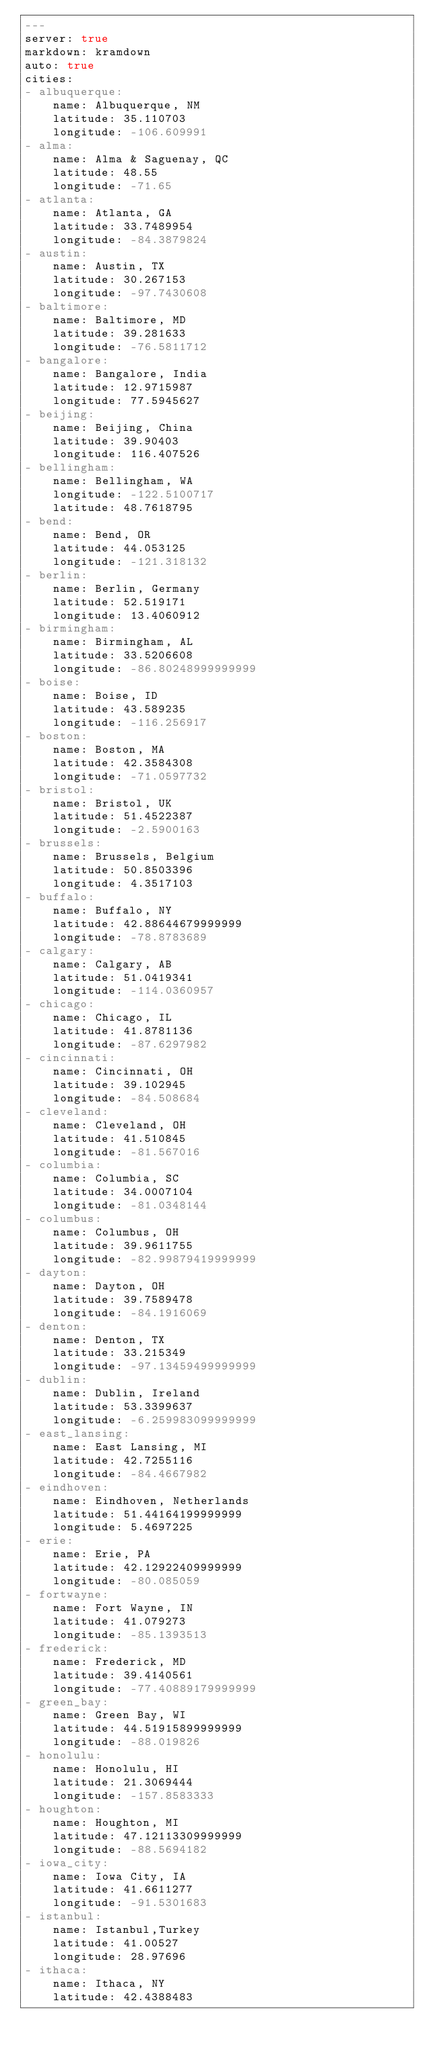Convert code to text. <code><loc_0><loc_0><loc_500><loc_500><_YAML_>---
server: true
markdown: kramdown
auto: true
cities:
- albuquerque:
    name: Albuquerque, NM
    latitude: 35.110703
    longitude: -106.609991
- alma:
    name: Alma & Saguenay, QC
    latitude: 48.55
    longitude: -71.65
- atlanta:
    name: Atlanta, GA
    latitude: 33.7489954
    longitude: -84.3879824
- austin:
    name: Austin, TX
    latitude: 30.267153
    longitude: -97.7430608
- baltimore:
    name: Baltimore, MD
    latitude: 39.281633
    longitude: -76.5811712
- bangalore:
    name: Bangalore, India
    latitude: 12.9715987
    longitude: 77.5945627
- beijing:
    name: Beijing, China
    latitude: 39.90403
    longitude: 116.407526
- bellingham:
    name: Bellingham, WA
    longitude: -122.5100717
    latitude: 48.7618795
- bend:
    name: Bend, OR
    latitude: 44.053125
    longitude: -121.318132
- berlin:
    name: Berlin, Germany
    latitude: 52.519171
    longitude: 13.4060912
- birmingham:
    name: Birmingham, AL
    latitude: 33.5206608
    longitude: -86.80248999999999
- boise:
    name: Boise, ID
    latitude: 43.589235
    longitude: -116.256917
- boston:
    name: Boston, MA
    latitude: 42.3584308
    longitude: -71.0597732
- bristol:
    name: Bristol, UK
    latitude: 51.4522387
    longitude: -2.5900163
- brussels:
    name: Brussels, Belgium
    latitude: 50.8503396
    longitude: 4.3517103
- buffalo:
    name: Buffalo, NY
    latitude: 42.88644679999999
    longitude: -78.8783689
- calgary:
    name: Calgary, AB
    latitude: 51.0419341
    longitude: -114.0360957
- chicago:
    name: Chicago, IL
    latitude: 41.8781136
    longitude: -87.6297982
- cincinnati:
    name: Cincinnati, OH
    latitude: 39.102945
    longitude: -84.508684
- cleveland:
    name: Cleveland, OH
    latitude: 41.510845
    longitude: -81.567016
- columbia:
    name: Columbia, SC
    latitude: 34.0007104
    longitude: -81.0348144
- columbus:
    name: Columbus, OH
    latitude: 39.9611755
    longitude: -82.99879419999999
- dayton:
    name: Dayton, OH
    latitude: 39.7589478
    longitude: -84.1916069
- denton:
    name: Denton, TX
    latitude: 33.215349
    longitude: -97.13459499999999
- dublin:
    name: Dublin, Ireland
    latitude: 53.3399637
    longitude: -6.259983099999999
- east_lansing:
    name: East Lansing, MI
    latitude: 42.7255116
    longitude: -84.4667982
- eindhoven:
    name: Eindhoven, Netherlands
    latitude: 51.44164199999999
    longitude: 5.4697225
- erie:
    name: Erie, PA
    latitude: 42.12922409999999
    longitude: -80.085059
- fortwayne:
    name: Fort Wayne, IN
    latitude: 41.079273
    longitude: -85.1393513
- frederick:
    name: Frederick, MD
    latitude: 39.4140561
    longitude: -77.40889179999999
- green_bay:
    name: Green Bay, WI
    latitude: 44.51915899999999
    longitude: -88.019826
- honolulu:
    name: Honolulu, HI
    latitude: 21.3069444
    longitude: -157.8583333
- houghton:
    name: Houghton, MI
    latitude: 47.12113309999999
    longitude: -88.5694182
- iowa_city:
    name: Iowa City, IA
    latitude: 41.6611277
    longitude: -91.5301683
- istanbul:
    name: Istanbul,Turkey
    latitude: 41.00527
    longitude: 28.97696
- ithaca:
    name: Ithaca, NY
    latitude: 42.4388483</code> 